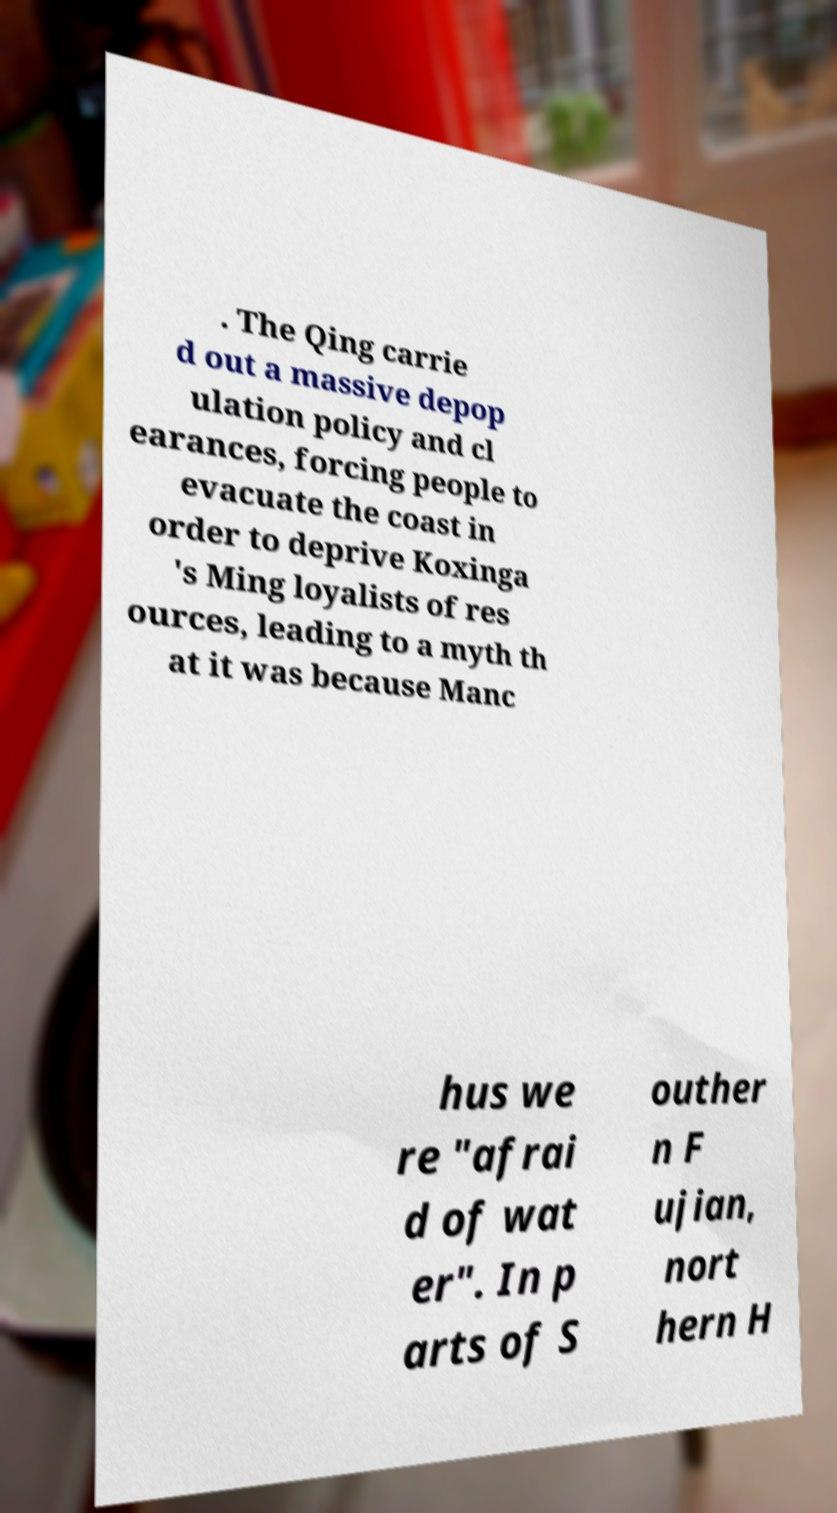There's text embedded in this image that I need extracted. Can you transcribe it verbatim? . The Qing carrie d out a massive depop ulation policy and cl earances, forcing people to evacuate the coast in order to deprive Koxinga 's Ming loyalists of res ources, leading to a myth th at it was because Manc hus we re "afrai d of wat er". In p arts of S outher n F ujian, nort hern H 